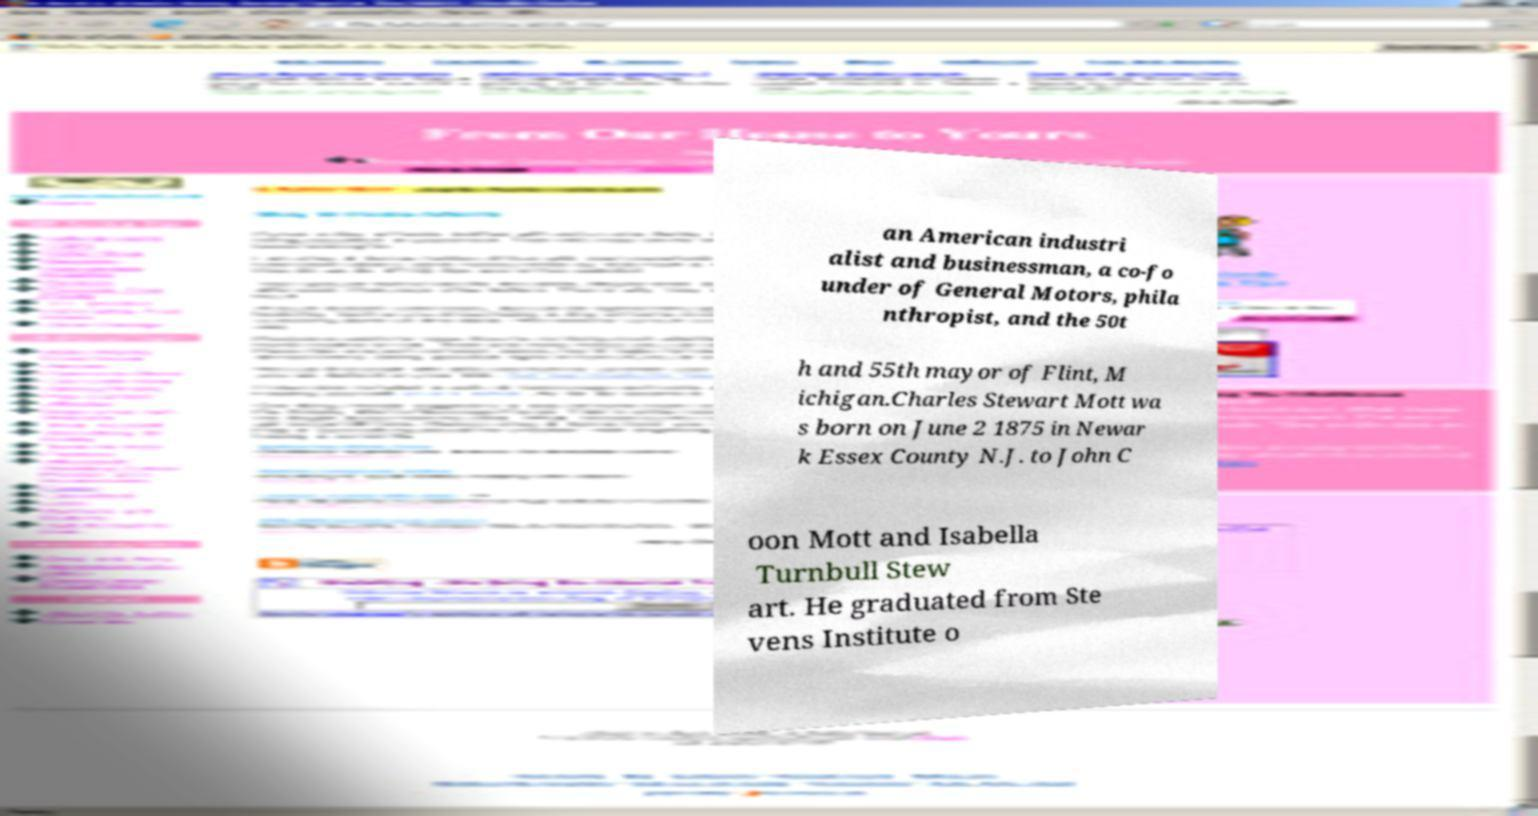I need the written content from this picture converted into text. Can you do that? an American industri alist and businessman, a co-fo under of General Motors, phila nthropist, and the 50t h and 55th mayor of Flint, M ichigan.Charles Stewart Mott wa s born on June 2 1875 in Newar k Essex County N.J. to John C oon Mott and Isabella Turnbull Stew art. He graduated from Ste vens Institute o 